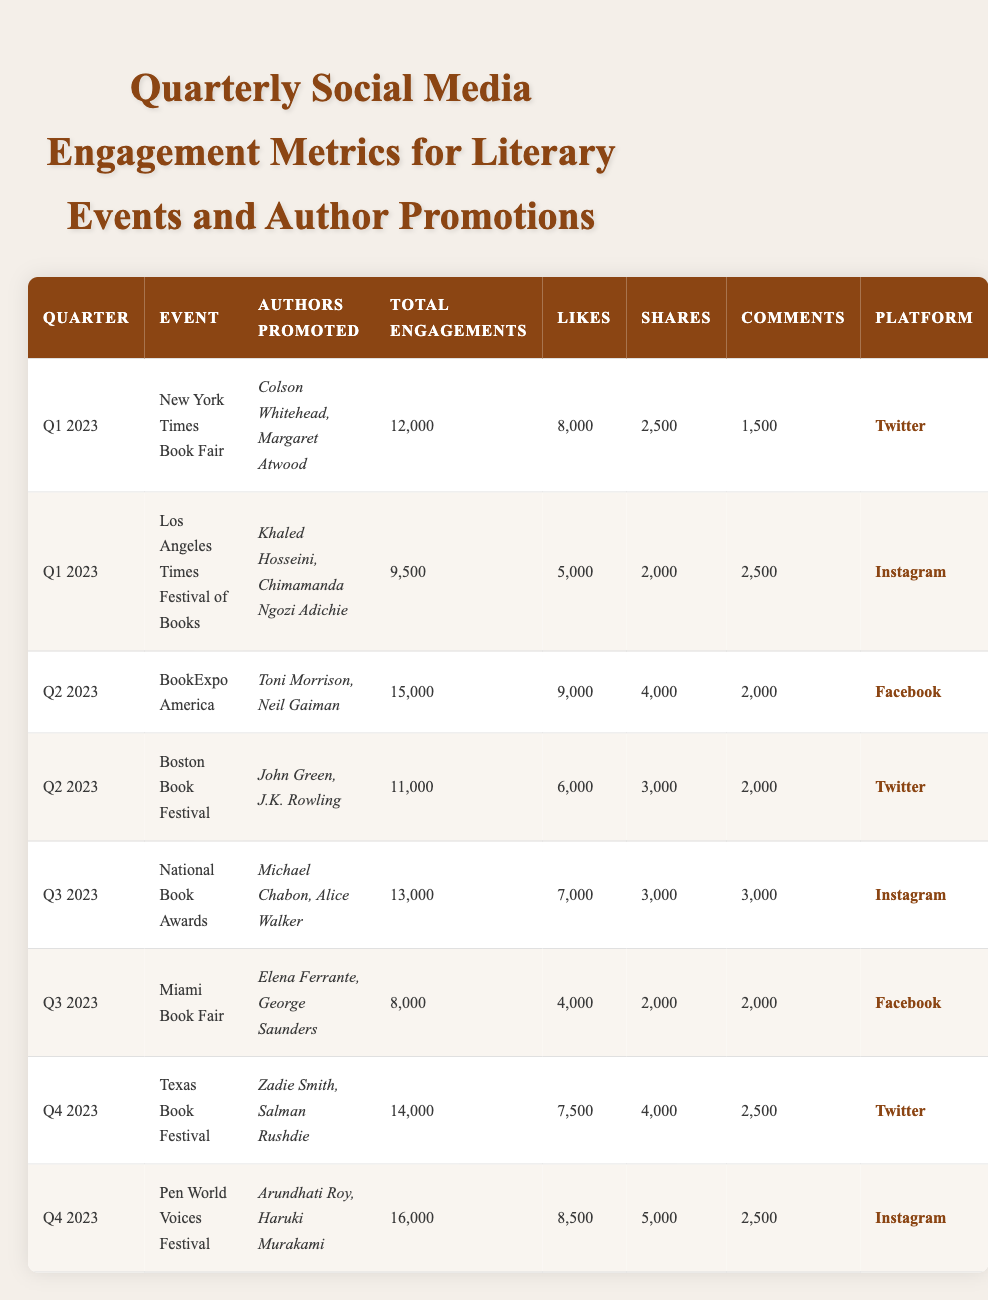What was the total number of engagements for the Boston Book Festival? The Boston Book Festival is listed in the table for Q2 2023 with a total engagement of 11,000.
Answer: 11,000 Which event had the highest likes in Q3 2023? In Q3 2023, the National Book Awards had the highest number of likes, with a total of 7,000.
Answer: 7,000 How many total engagements were recorded in Q4 2023? Q4 2023 has two events: Texas Book Festival (14,000) and Pen World Voices Festival (16,000). Summing these gives 14,000 + 16,000 = 30,000.
Answer: 30,000 Did the Miami Book Fair have more comments than the National Book Awards? The Miami Book Fair has 2,000 comments, while the National Book Awards has 3,000 comments. Since 2,000 is less than 3,000, the statement is false.
Answer: No What is the average number of likes across all events in Q1 2023? In Q1 2023, likes were 8,000 for the New York Times Book Fair and 5,000 for the Los Angeles Times Festival of Books. The average is calculated as (8,000 + 5,000) / 2 = 6,500.
Answer: 6,500 Which author's promotions generated the most total engagements in Q2 2023? In Q2 2023, BookExpo America promoted Toni Morrison and Neil Gaiman with 15,000 total engagements, which is the highest for that quarter.
Answer: BookExpo America Was there a higher total engagement in Q3 2023 compared to Q1 2023? Q3 2023 had a total engagement of 13,000 (National Book Awards, 13,000 + Miami Book Fair, 8,000 = 21,000), whereas Q1 2023 had a combined total of 21,500 (New York Times Book Fair, 12,000 + Los Angeles Times Festival of Books, 9,500). Thus, Q1 2023 had higher engagement.
Answer: No What percentage of the total engagements for the Texas Book Festival came from shares? The Texas Book Festival had 14,000 total engagements with 4,000 shares. The percentage is calculated as (4,000 / 14,000) * 100 = 28.57%.
Answer: 28.57% Which platform had the highest total engagements across Q2 2023 events? In Q2 2023, BookExpo America (15,000) was on Facebook, and the Boston Book Festival (11,000) was on Twitter. Summing these gives Facebook 15,000 and Twitter 11,000, so Facebook had the highest.
Answer: Facebook How many total engagements were generated for events that took place on Instagram in Q4 2023? In Q4 2023, there are two events on Instagram: the Pen World Voices Festival with 16,000 engagements and the Texas Book Festival which is on Twitter. Thus, only the Pen World Voices Festival contributes to the total for Instagram in Q4 2023, which is 16,000.
Answer: 16,000 